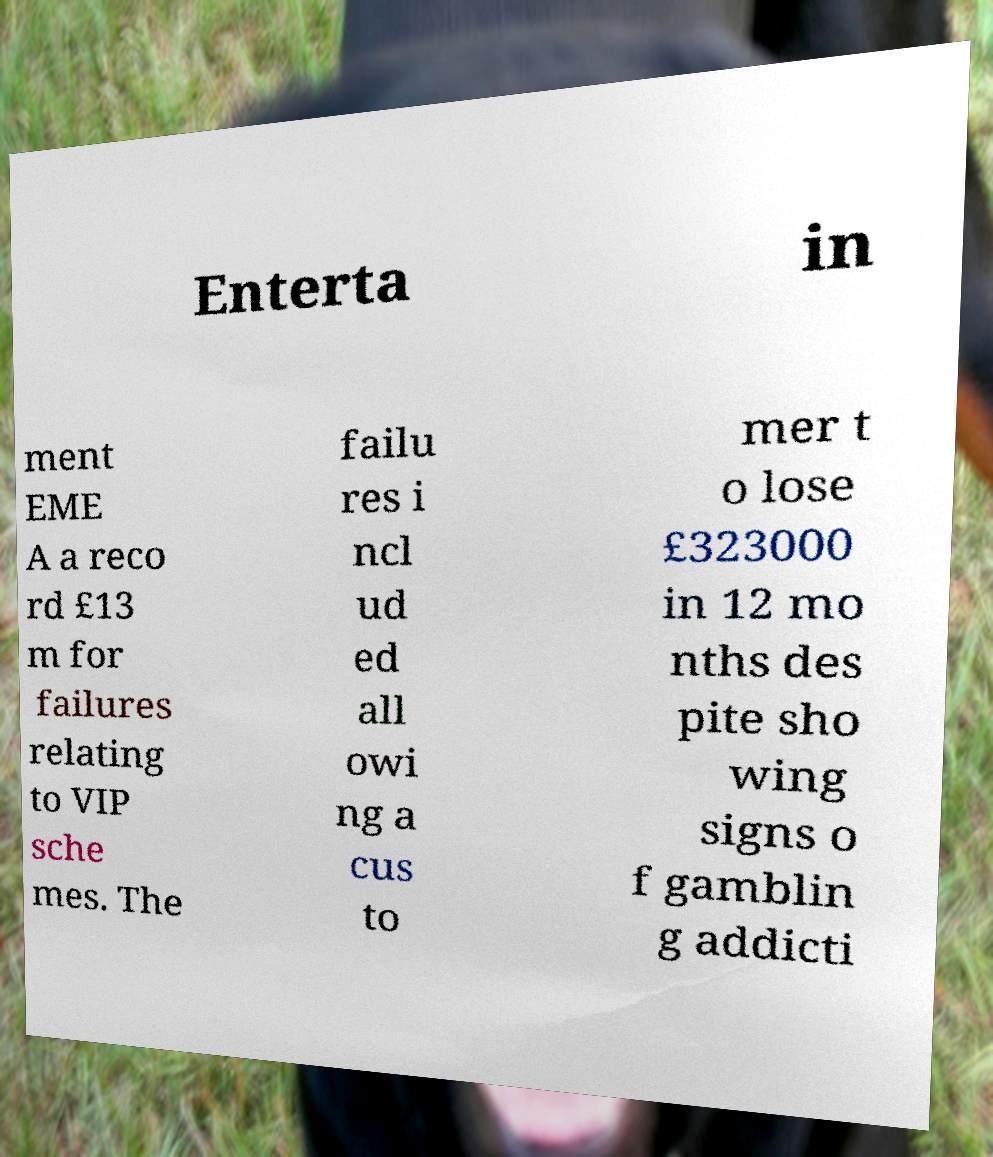Please identify and transcribe the text found in this image. Enterta in ment EME A a reco rd £13 m for failures relating to VIP sche mes. The failu res i ncl ud ed all owi ng a cus to mer t o lose £323000 in 12 mo nths des pite sho wing signs o f gamblin g addicti 